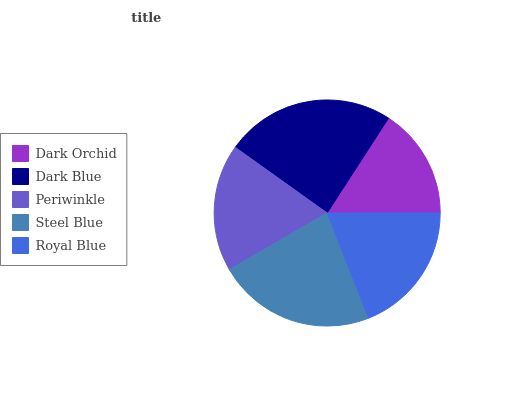Is Dark Orchid the minimum?
Answer yes or no. Yes. Is Dark Blue the maximum?
Answer yes or no. Yes. Is Periwinkle the minimum?
Answer yes or no. No. Is Periwinkle the maximum?
Answer yes or no. No. Is Dark Blue greater than Periwinkle?
Answer yes or no. Yes. Is Periwinkle less than Dark Blue?
Answer yes or no. Yes. Is Periwinkle greater than Dark Blue?
Answer yes or no. No. Is Dark Blue less than Periwinkle?
Answer yes or no. No. Is Royal Blue the high median?
Answer yes or no. Yes. Is Royal Blue the low median?
Answer yes or no. Yes. Is Dark Blue the high median?
Answer yes or no. No. Is Steel Blue the low median?
Answer yes or no. No. 